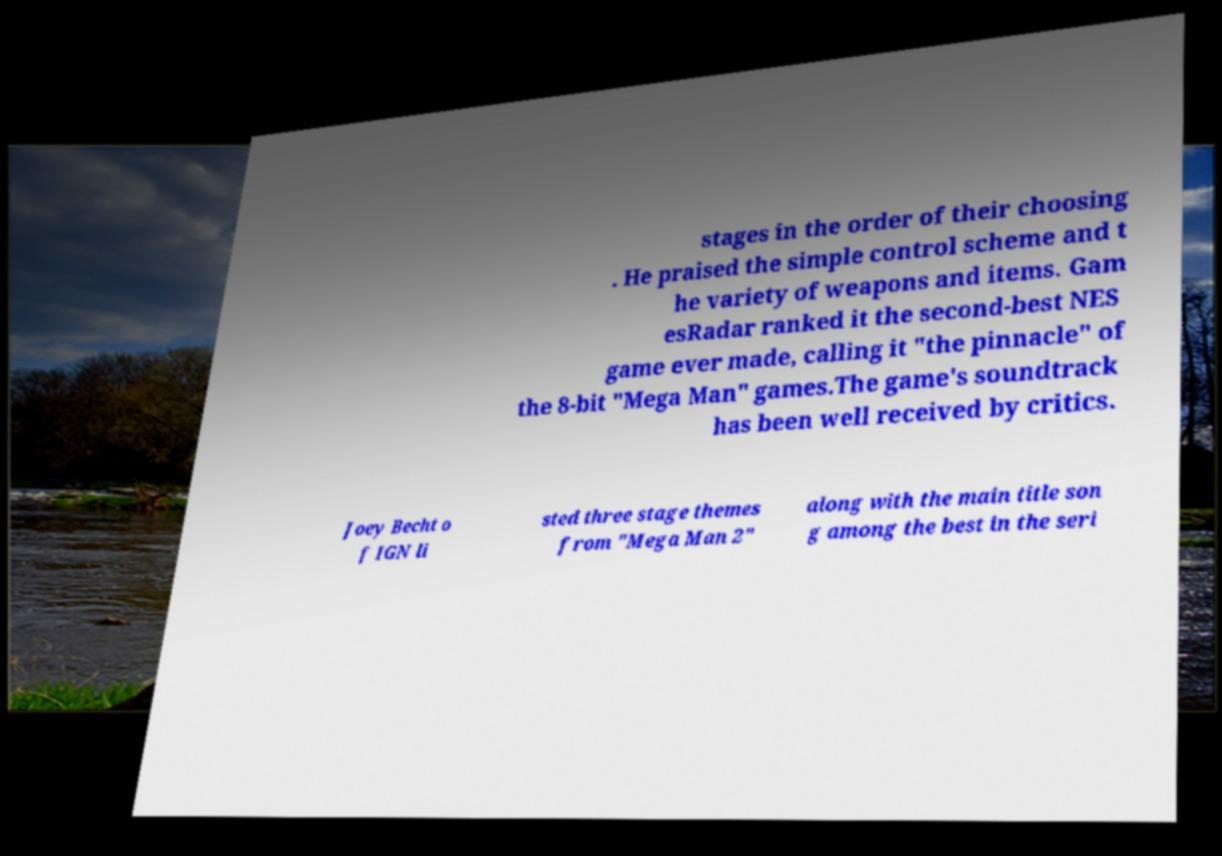I need the written content from this picture converted into text. Can you do that? stages in the order of their choosing . He praised the simple control scheme and t he variety of weapons and items. Gam esRadar ranked it the second-best NES game ever made, calling it "the pinnacle" of the 8-bit "Mega Man" games.The game's soundtrack has been well received by critics. Joey Becht o f IGN li sted three stage themes from "Mega Man 2" along with the main title son g among the best in the seri 